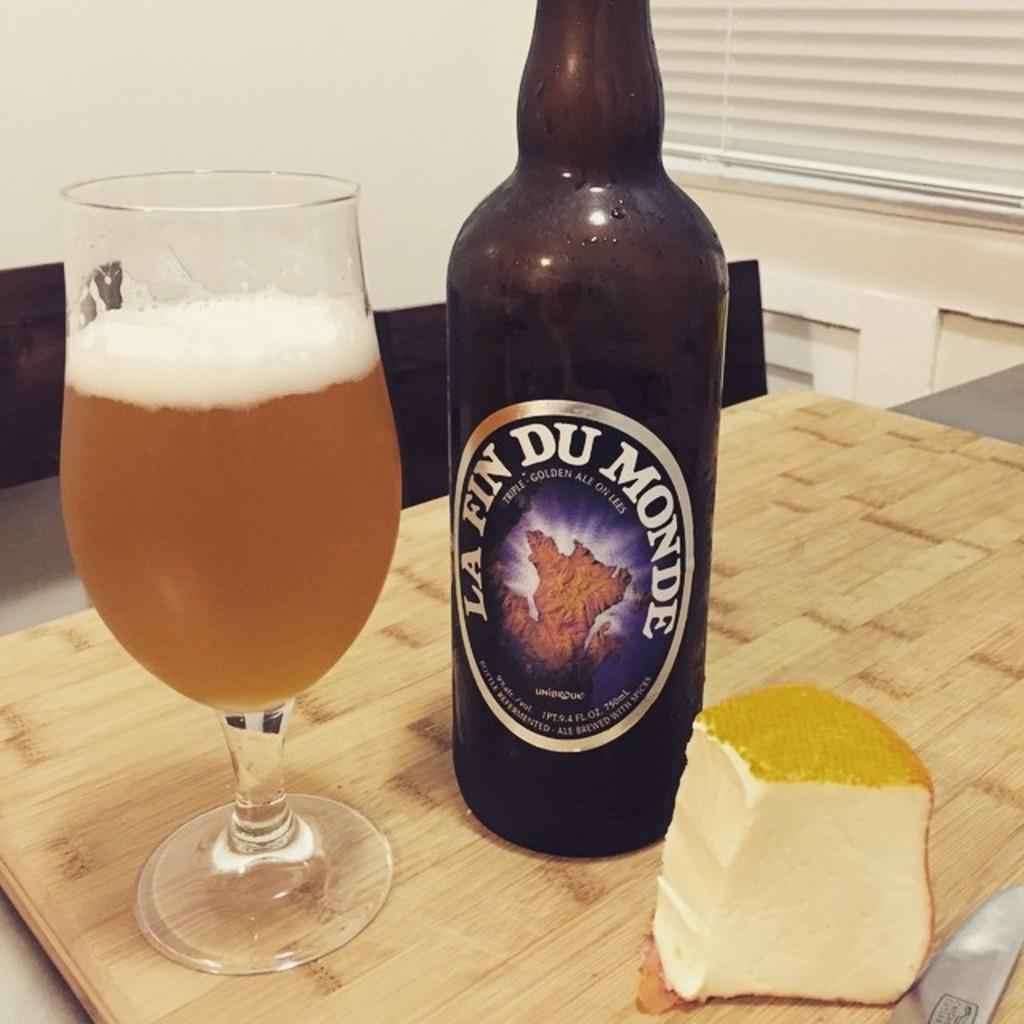Provide a one-sentence caption for the provided image. A bottle of La Fin Du Monde sits next to a glass of beer and chunk of cheese. 